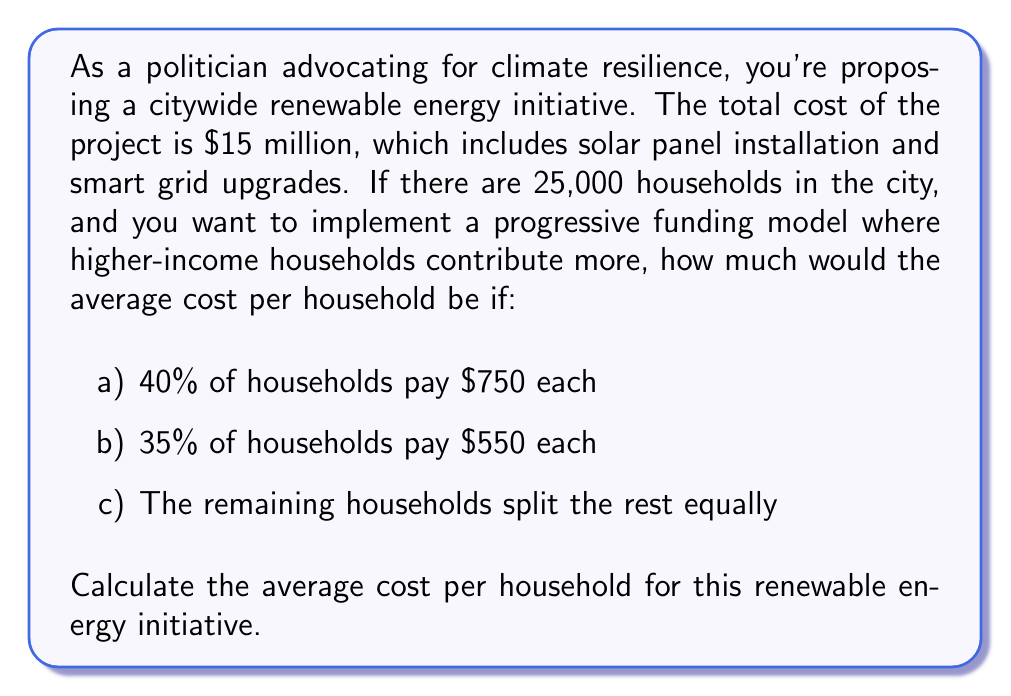Solve this math problem. Let's break this down step-by-step:

1) First, let's calculate how many households are in each category:
   a) 40% of 25,000 = $0.40 \times 25,000 = 10,000$ households
   b) 35% of 25,000 = $0.35 \times 25,000 = 8,750$ households
   c) Remaining: $25,000 - 10,000 - 8,750 = 6,250$ households

2) Now, let's calculate the total contribution from groups a and b:
   a) $10,000 \times \$750 = \$7,500,000$
   b) $8,750 \times \$550 = \$4,812,500$

3) The total contribution from a and b:
   $\$7,500,000 + \$4,812,500 = \$12,312,500$

4) The remaining amount to be paid by group c:
   $\$15,000,000 - \$12,312,500 = \$2,687,500$

5) The amount each household in group c needs to pay:
   $\$2,687,500 \div 6,250 = \$430$

6) To calculate the average cost per household, we need to sum all payments and divide by the total number of households:

   $$\text{Average Cost} = \frac{\$7,500,000 + \$4,812,500 + \$2,687,500}{25,000}$$

   $$= \frac{\$15,000,000}{25,000} = \$600$$

Therefore, the average cost per household for this renewable energy initiative is $600.
Answer: $600 per household 